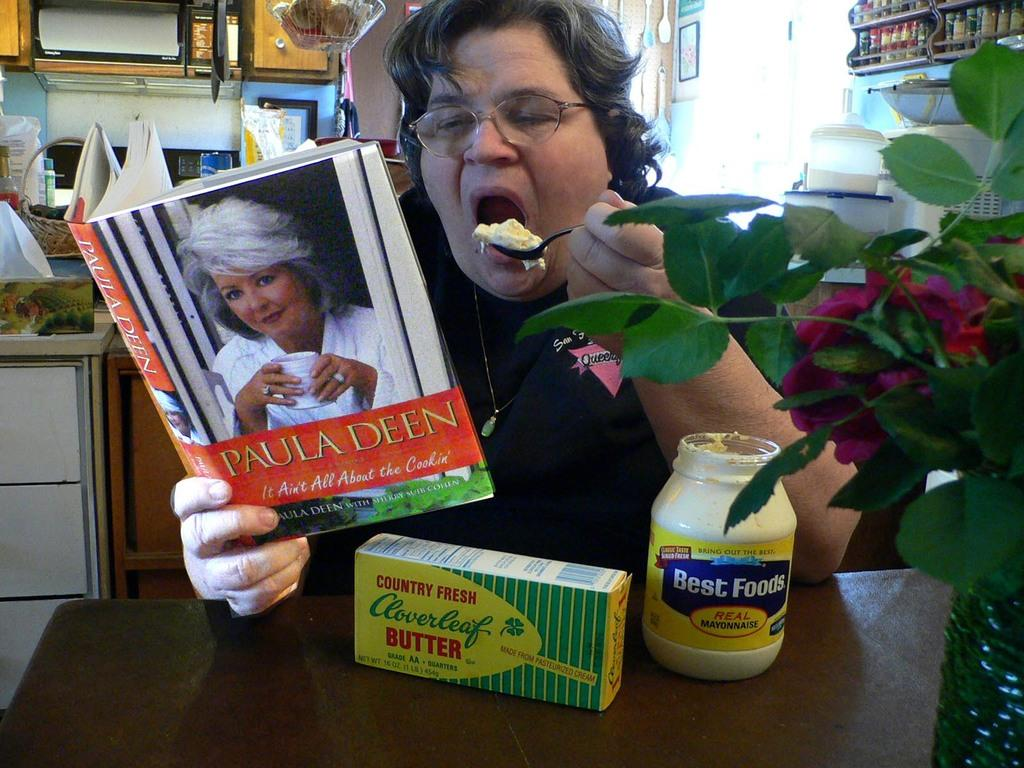<image>
Share a concise interpretation of the image provided. Next to the Cloverleaf butter is a jar of Best Foods real mayonnaise. 